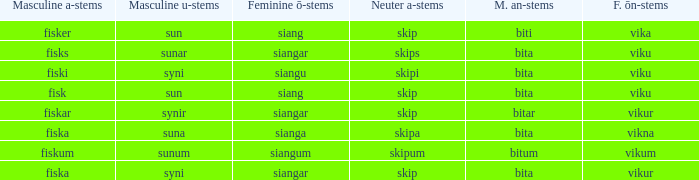What is the masculine an form for the word with a feminine ö ending of siangar and a masculine u ending of sunar? Bita. 